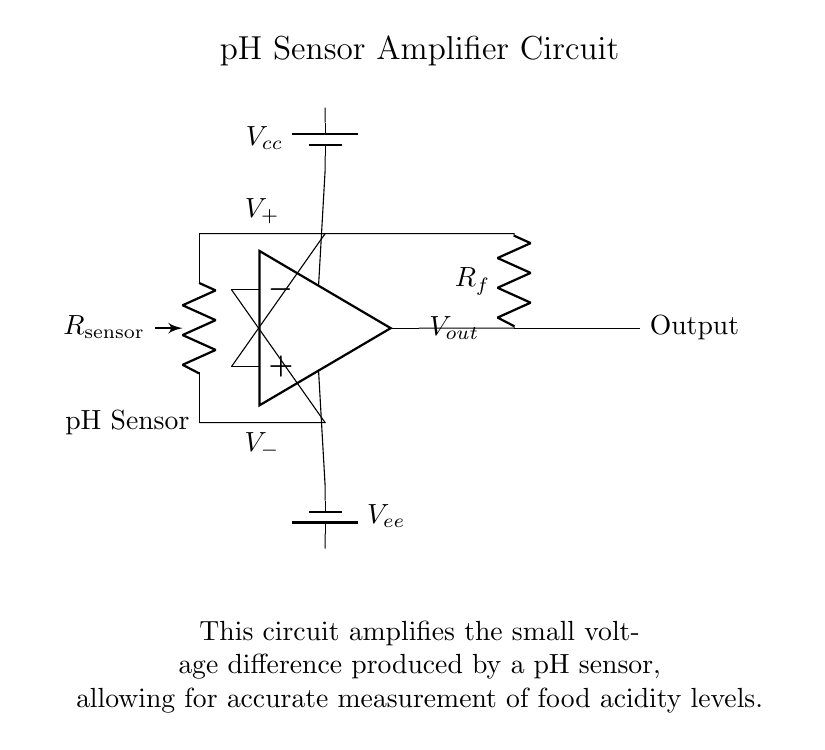What type of sensor is used in this circuit? The circuit uses a pH sensor, indicated clearly in the diagram and labeled as such.
Answer: pH sensor What is the function of the resistor labeled R_f? R_f is the feedback resistor, which is crucial for setting the gain of the operational amplifier, helping amplify the voltage difference generated by the pH sensor.
Answer: Feedback resistor What is the output of the amplifier labeled as? The output of the amplifier is labeled as "Output," which is where the amplified signal is available for measurement.
Answer: Output What is the voltage supply to the operational amplifier? The circuit shows two battery symbols connected to the operational amplifier, with V_cc as the positive supply and V_ee as the negative supply; hence the supply voltages are labeled as V_cc and V_ee.
Answer: V_cc and V_ee How are the pH sensor connections made to the op-amp? The pH sensor connections are made by a direct connection to both the positive and negative inputs of the operational amplifier, which is indicated by the lines connecting the sensor to the op-amp terminals.
Answer: Direct connection What does the presence of the capacitor indicate regarding the circuit behavior? While the diagram does not show a capacitor directly, any typical amplifier circuit may include a capacitor to filter noise or stabilize the signal. In this case, we can infer that capacitors are often essential in amplifiers for filtering.
Answer: Signal stability What does the amplification of pH sensor voltage allow for? Amplification enables the small voltage changes from the pH sensor to be measurable and interpretable, thereby allowing accurate monitoring of food acidity levels, which is essential for safety in food handling.
Answer: Accurate measurement 